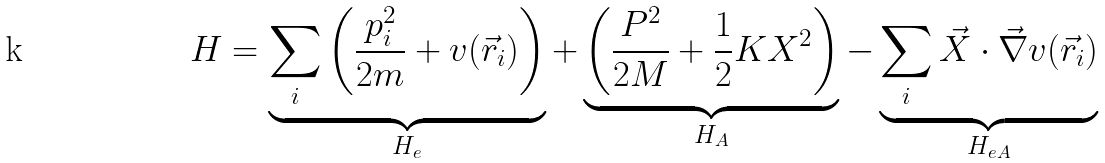Convert formula to latex. <formula><loc_0><loc_0><loc_500><loc_500>H = \underbrace { \sum _ { i } \left ( \frac { p _ { i } ^ { 2 } } { 2 m } + v ( \vec { r } _ { i } ) \right ) } _ { H _ { e } } + \underbrace { \left ( \frac { P ^ { 2 } } { 2 M } + \frac { 1 } { 2 } K X ^ { 2 } \right ) } _ { H _ { A } } - \underbrace { \sum _ { i } \vec { X } \cdot \vec { \nabla } v ( \vec { r } _ { i } ) } _ { H _ { e A } }</formula> 